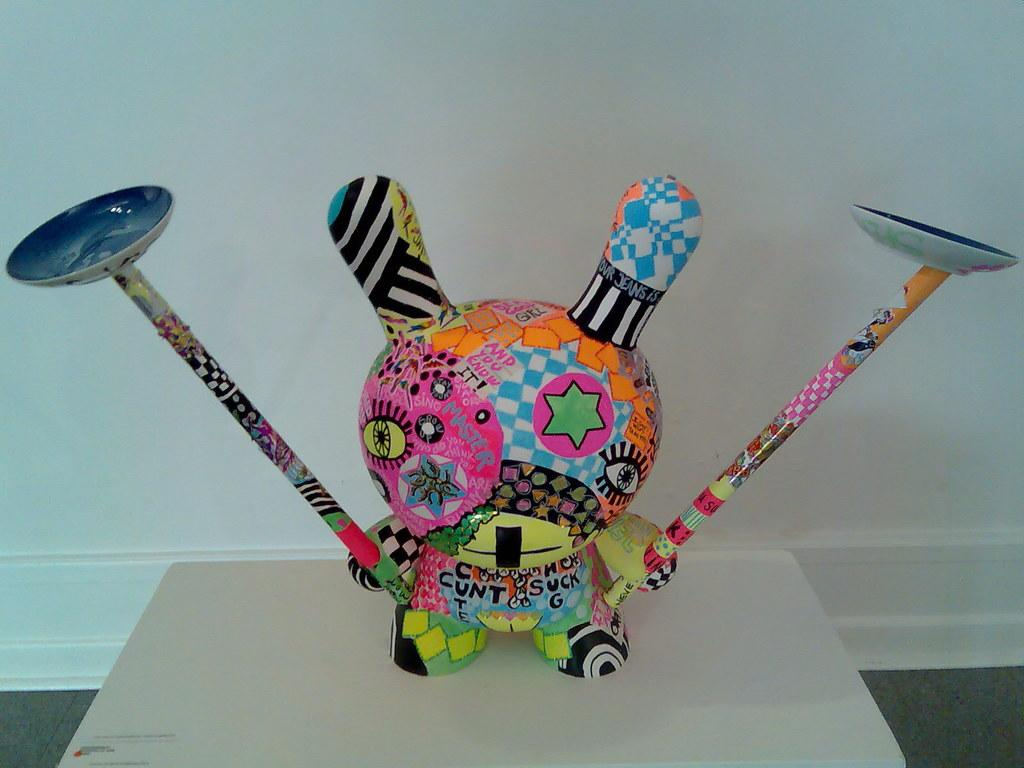What is the main subject in the front of the image? There is a colorful object in the front of the image. What can be seen in the background of the image? There is a white wall in the background of the image. How much profit does the duck in the image generate? There is no duck present in the image, so it is not possible to determine any profit generated. 